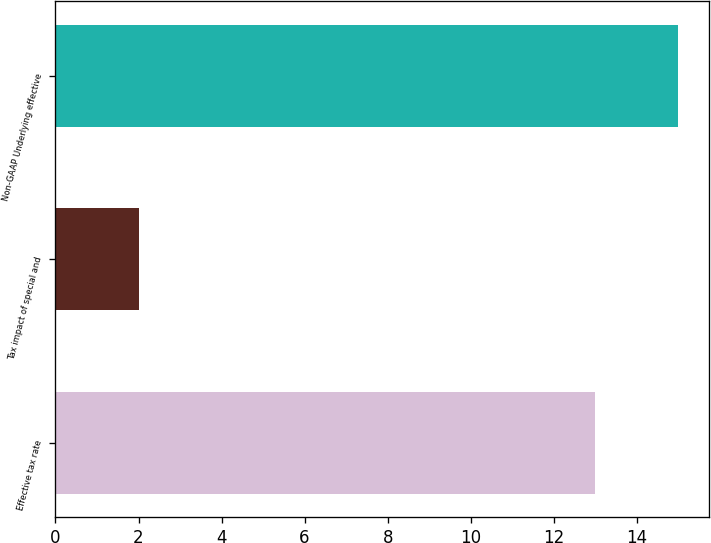Convert chart. <chart><loc_0><loc_0><loc_500><loc_500><bar_chart><fcel>Effective tax rate<fcel>Tax impact of special and<fcel>Non-GAAP Underlying effective<nl><fcel>13<fcel>2<fcel>15<nl></chart> 